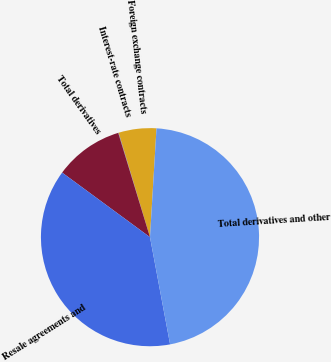<chart> <loc_0><loc_0><loc_500><loc_500><pie_chart><fcel>Foreign exchange contracts<fcel>Interest-rate contracts<fcel>Total derivatives<fcel>Resale agreements and<fcel>Total derivatives and other<nl><fcel>5.59%<fcel>0.07%<fcel>10.2%<fcel>38.04%<fcel>46.1%<nl></chart> 